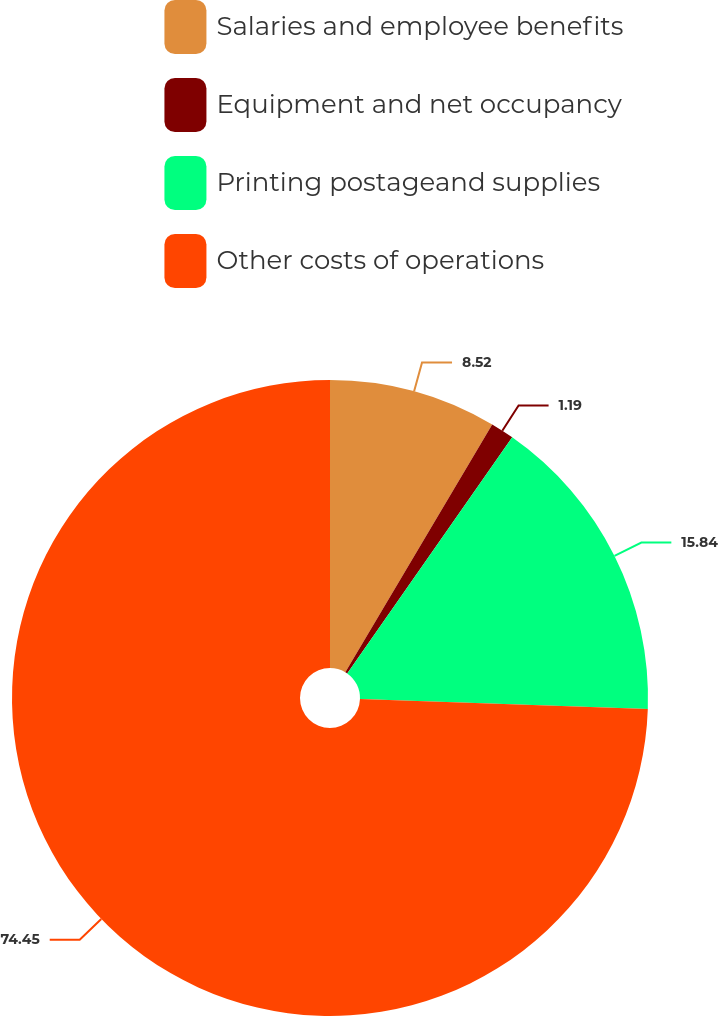Convert chart to OTSL. <chart><loc_0><loc_0><loc_500><loc_500><pie_chart><fcel>Salaries and employee benefits<fcel>Equipment and net occupancy<fcel>Printing postageand supplies<fcel>Other costs of operations<nl><fcel>8.52%<fcel>1.19%<fcel>15.84%<fcel>74.45%<nl></chart> 